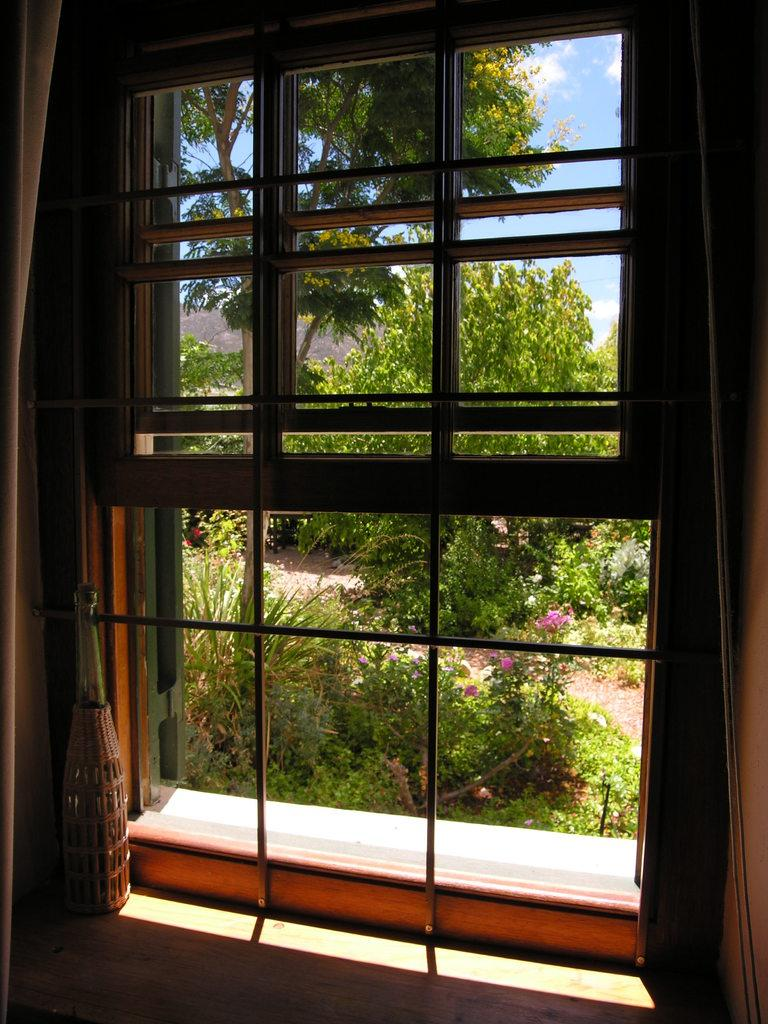What can be seen through the window in the image? There is a window in the image, and grass, a plant, a tree, and the sky are visible outside the window. What object is present in the image besides the window? There is a bottle in the image. What type of vegetation is visible outside the window? Grass, a plant, and a tree are visible outside the window. What part of the natural environment can be seen through the window? The sky is visible outside the window. What type of account is being discussed in the image? There is no account being discussed in the image. How many cubs are visible in the image? There are no cubs present in the image. 